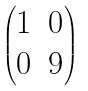<formula> <loc_0><loc_0><loc_500><loc_500>\begin{pmatrix} 1 & 0 \\ 0 & 9 \end{pmatrix}</formula> 